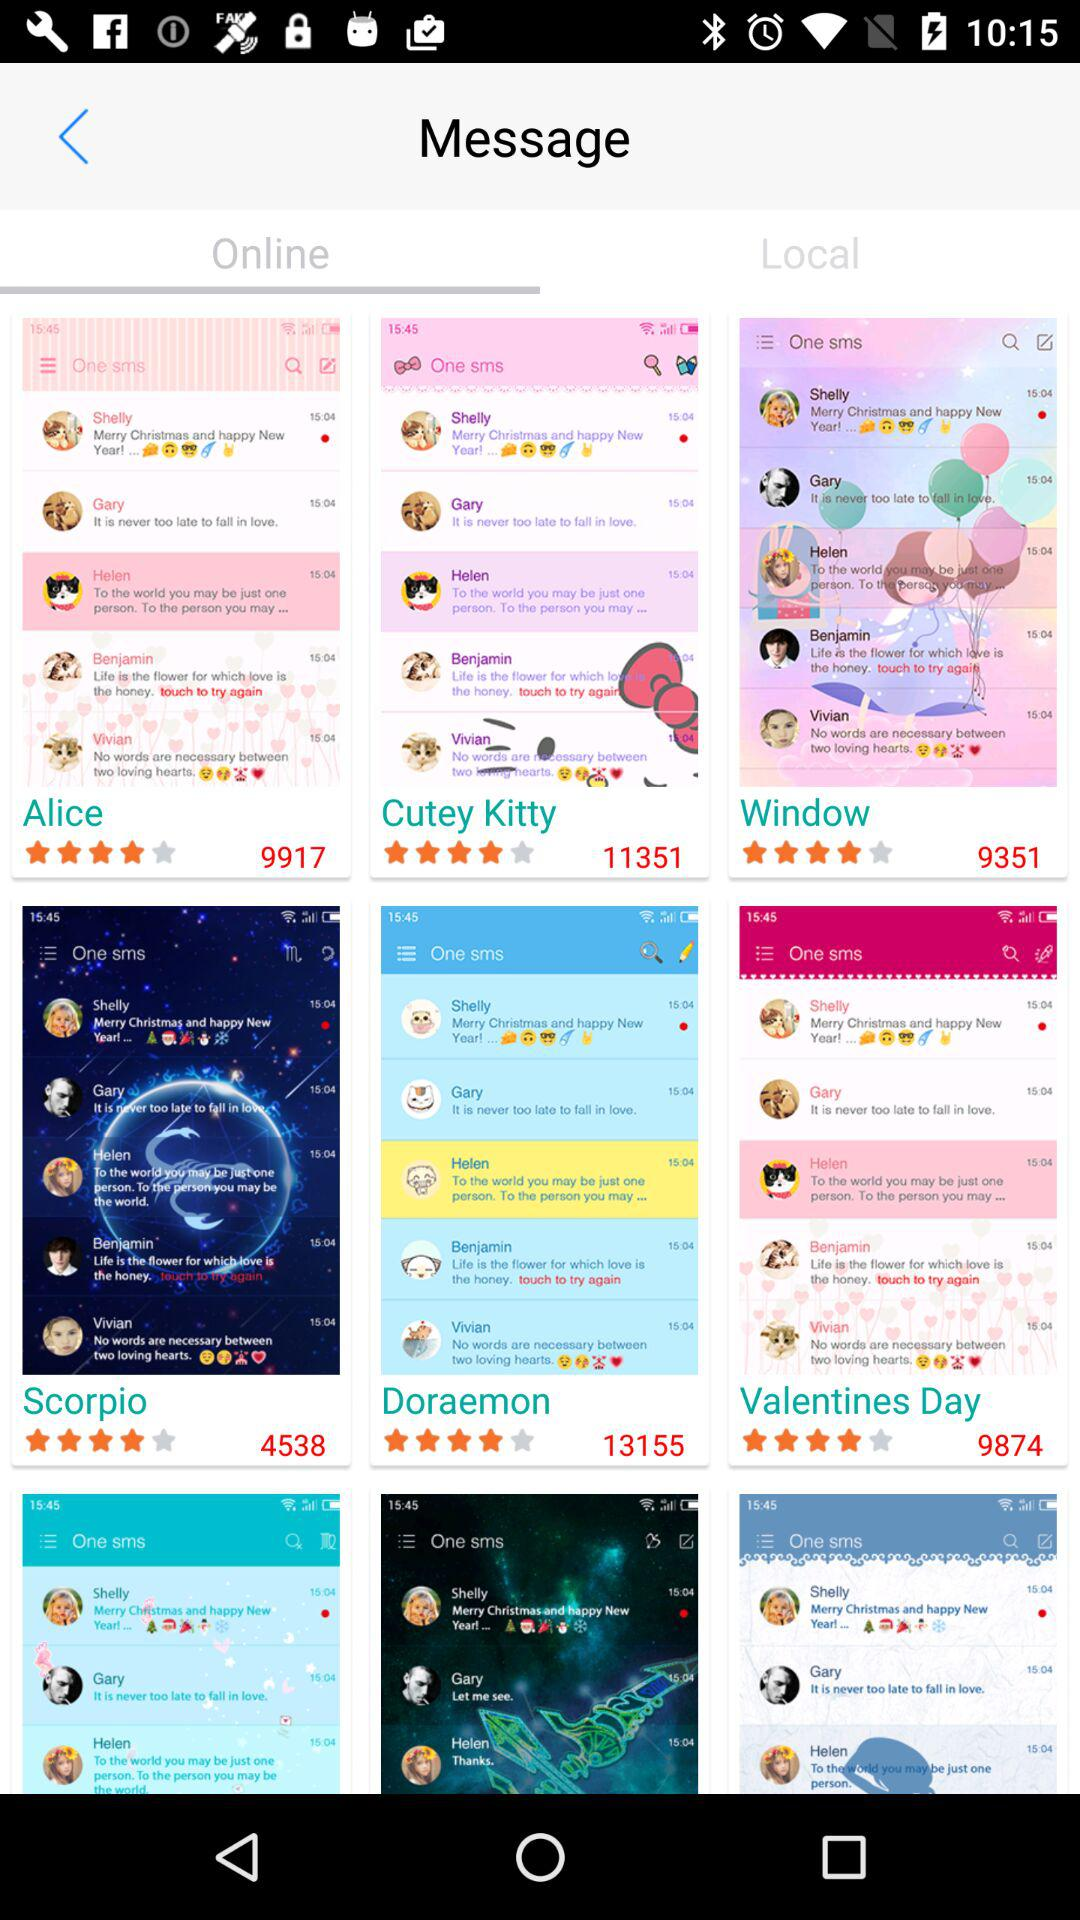What is rating for "Cutey Kitty"? The rating is 4 stars. 